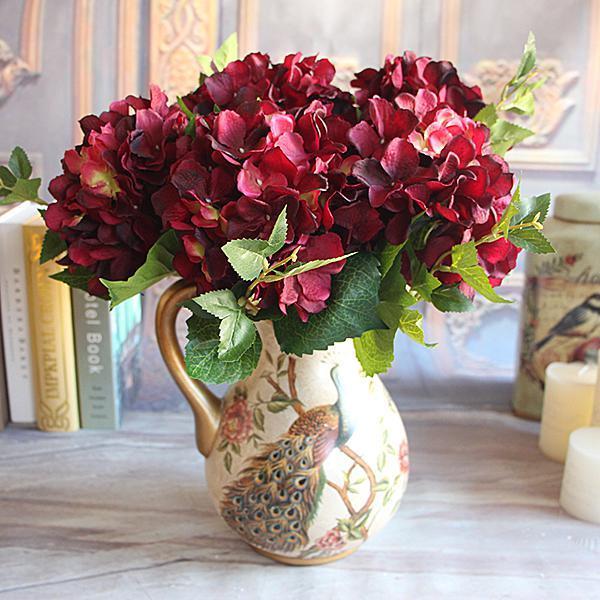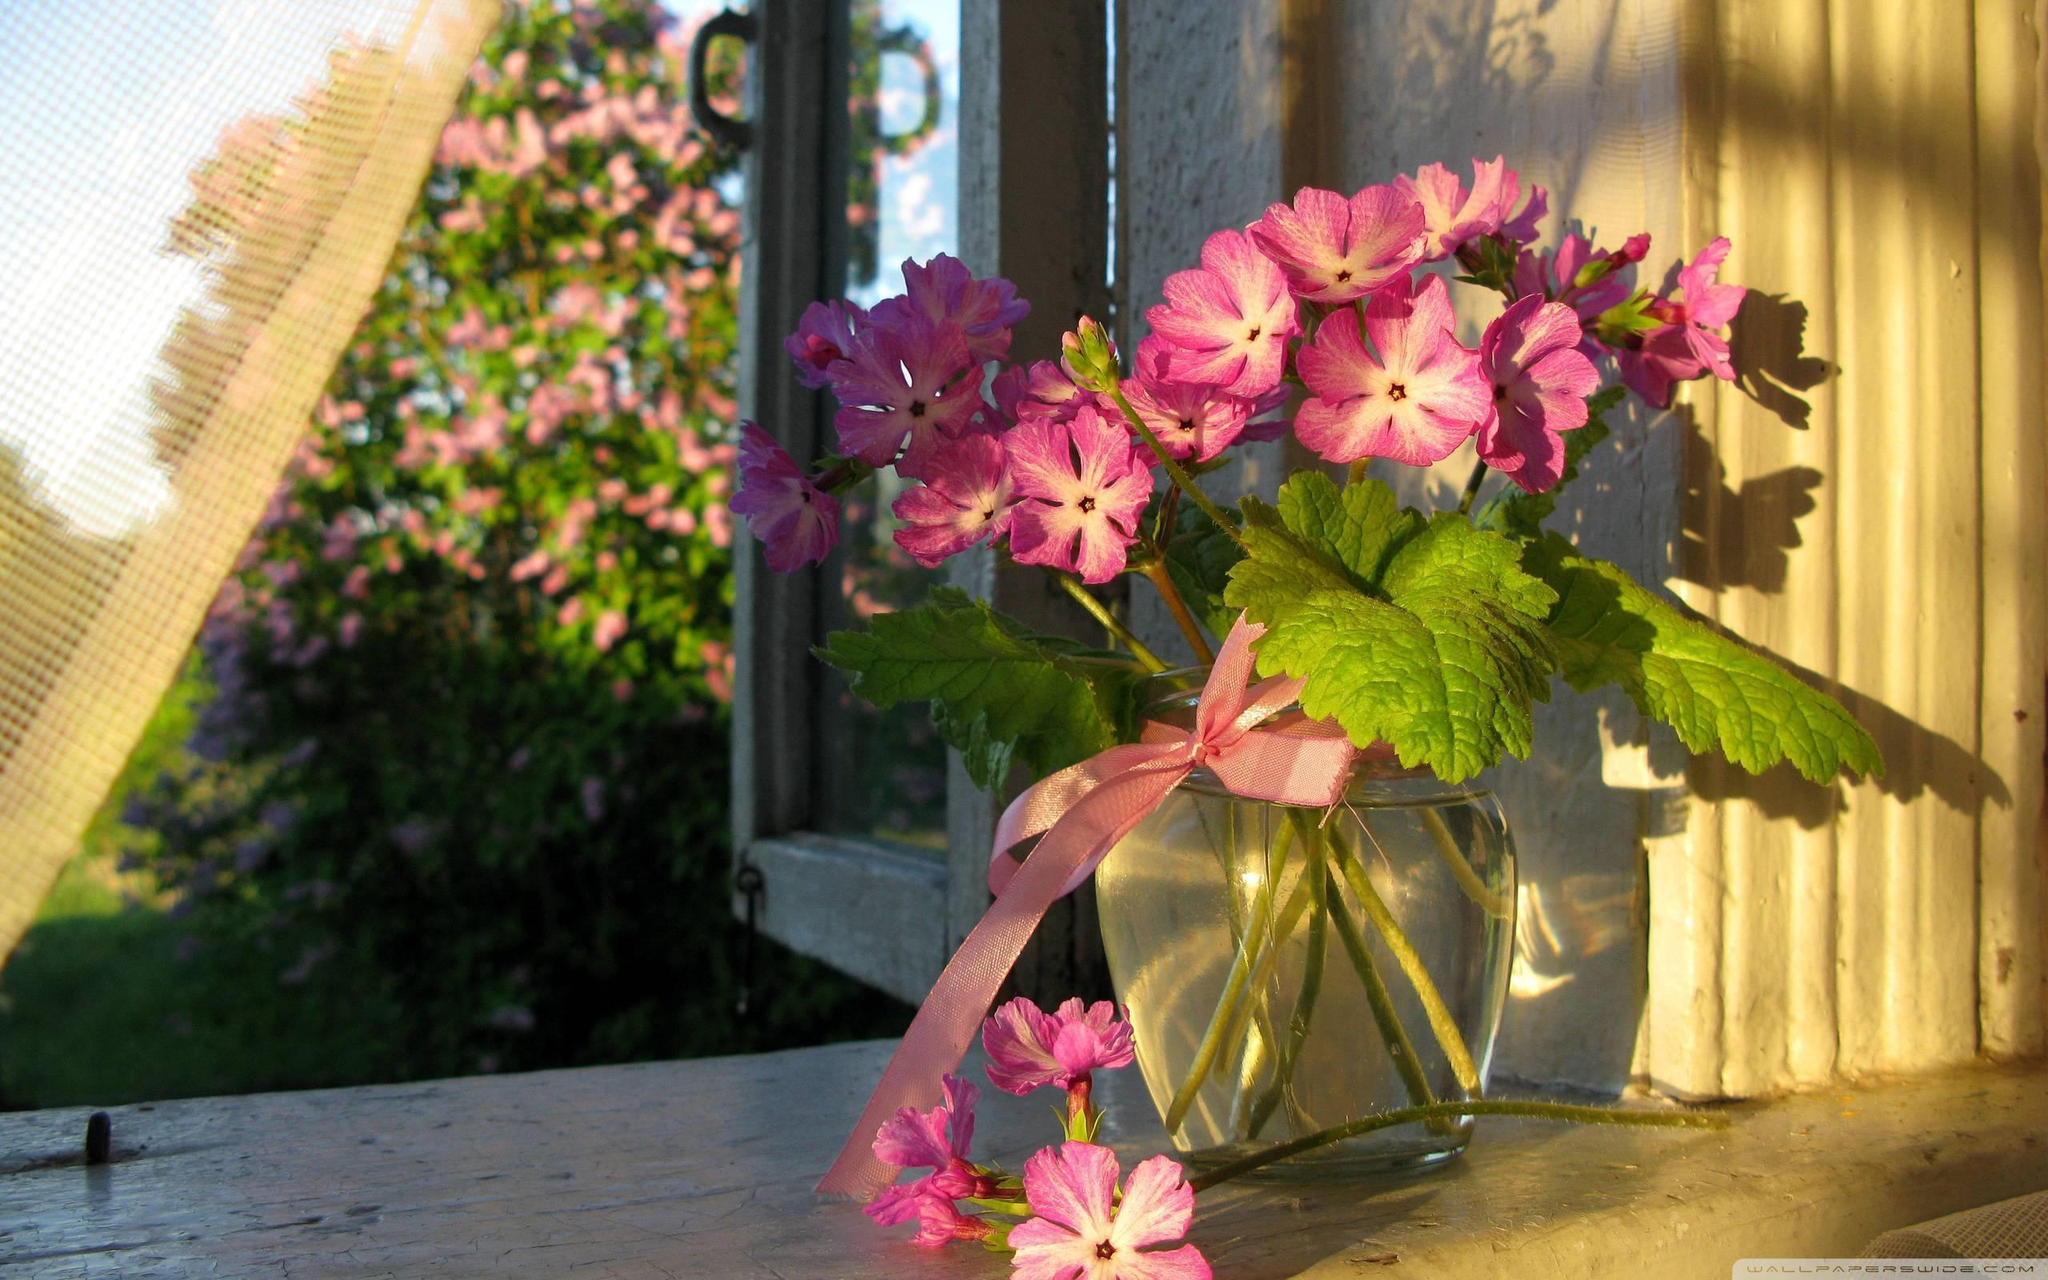The first image is the image on the left, the second image is the image on the right. Evaluate the accuracy of this statement regarding the images: "One of the floral arrangements has only blue flowers.". Is it true? Answer yes or no. No. 